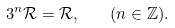<formula> <loc_0><loc_0><loc_500><loc_500>3 ^ { n } \mathcal { R } = \mathcal { R } , \quad ( n \in \mathbb { Z } ) .</formula> 